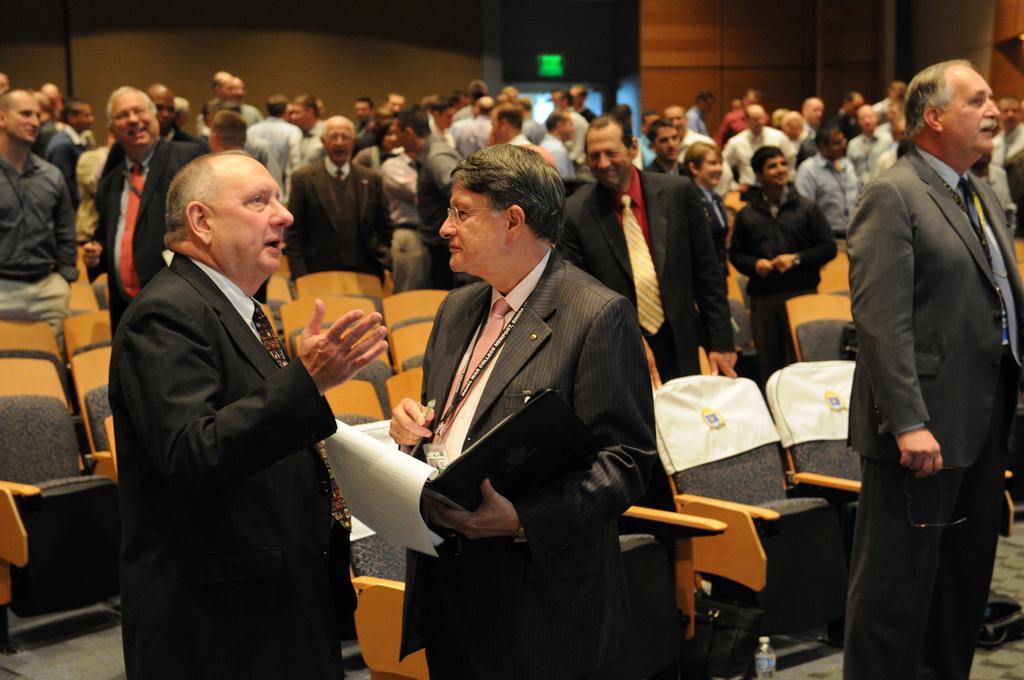Can you describe this image briefly? This picture is an inside view of an auditorium. In this picture we can see a group of people are standing and chairs, wall, sign board are there. At the bottom of the image we can see bottle, floor are there. 